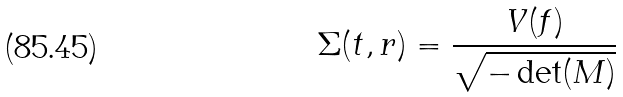<formula> <loc_0><loc_0><loc_500><loc_500>\Sigma ( t , r ) = \frac { V ( f ) } { \sqrt { - \det ( M ) } }</formula> 